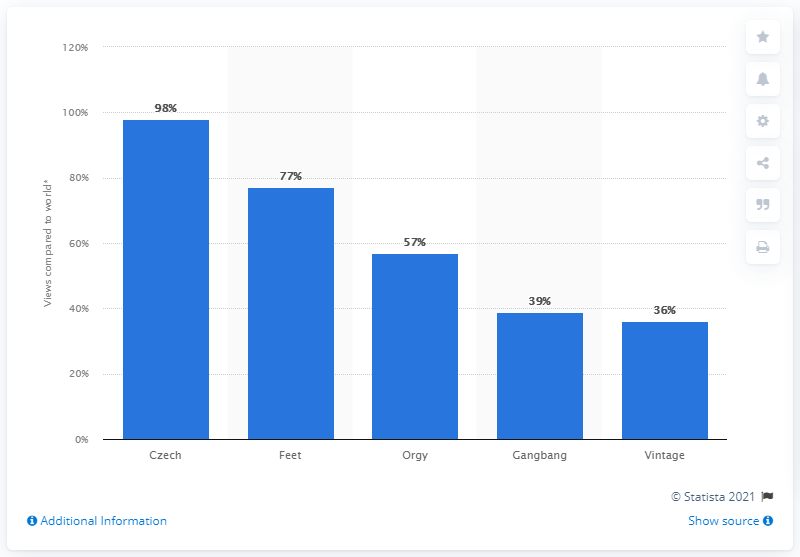Give some essential details in this illustration. According to Pornhub.com, the leading relative category of content viewed in Poland in 2019 was Czech content. In Poland, "Czech" was viewed significantly more often than it was viewed worldwide, with a difference of 98 times. 